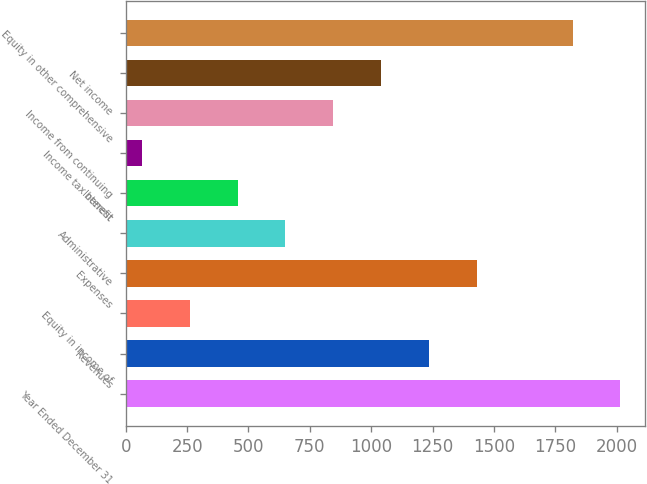Convert chart to OTSL. <chart><loc_0><loc_0><loc_500><loc_500><bar_chart><fcel>Year Ended December 31<fcel>Revenues<fcel>Equity in income of<fcel>Expenses<fcel>Administrative<fcel>Interest<fcel>Income tax benefit<fcel>Income from continuing<fcel>Net income<fcel>Equity in other comprehensive<nl><fcel>2015<fcel>1235.4<fcel>260.9<fcel>1430.3<fcel>650.7<fcel>455.8<fcel>66<fcel>845.6<fcel>1040.5<fcel>1820.1<nl></chart> 